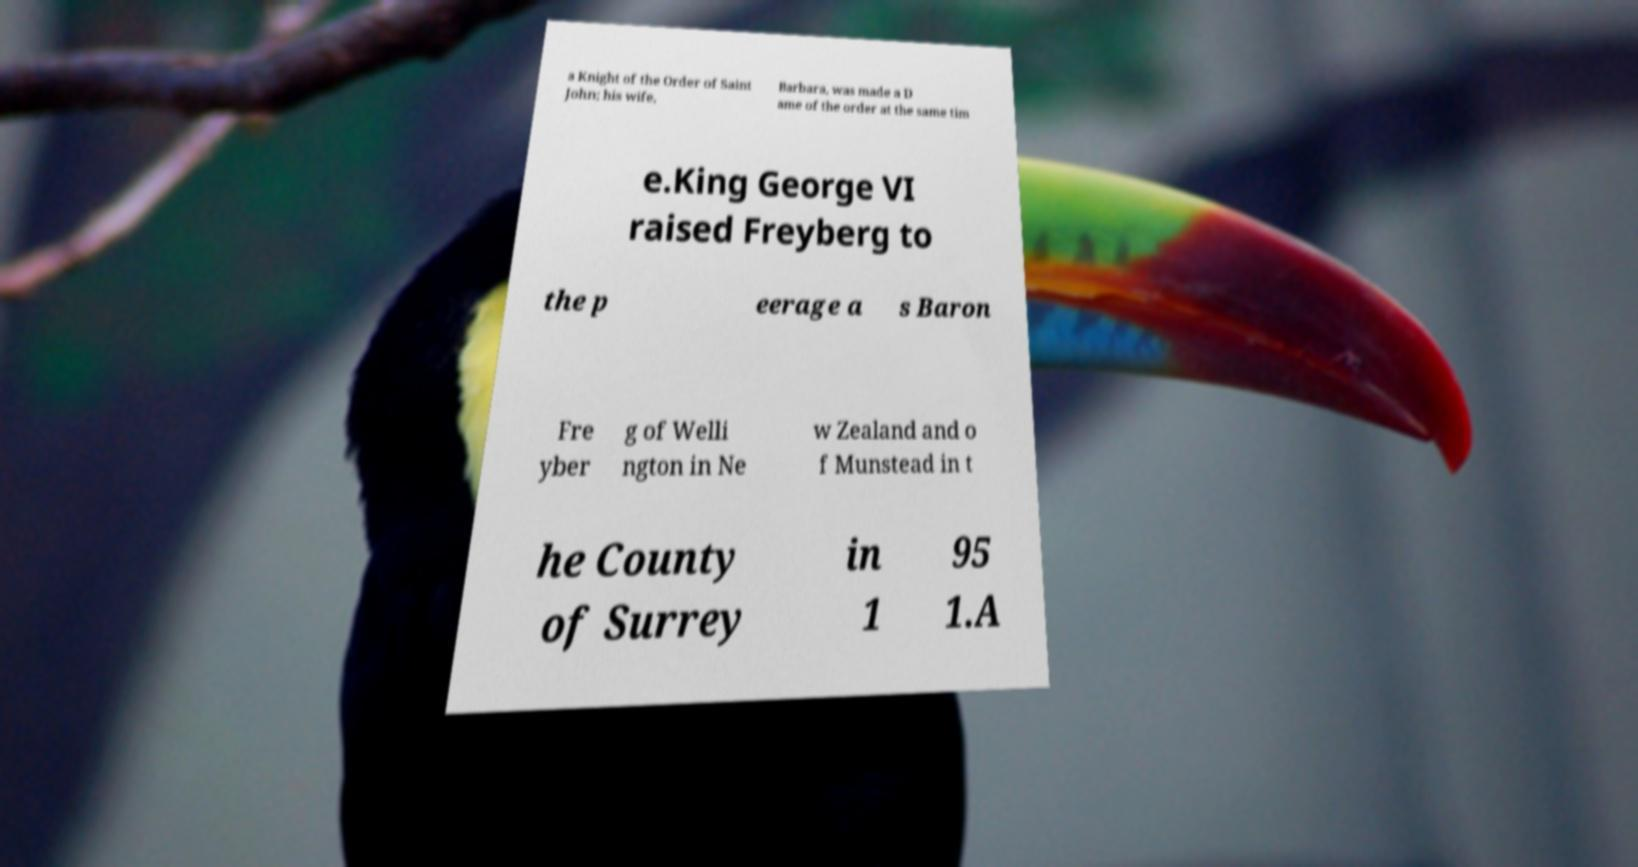Could you assist in decoding the text presented in this image and type it out clearly? a Knight of the Order of Saint John; his wife, Barbara, was made a D ame of the order at the same tim e.King George VI raised Freyberg to the p eerage a s Baron Fre yber g of Welli ngton in Ne w Zealand and o f Munstead in t he County of Surrey in 1 95 1.A 